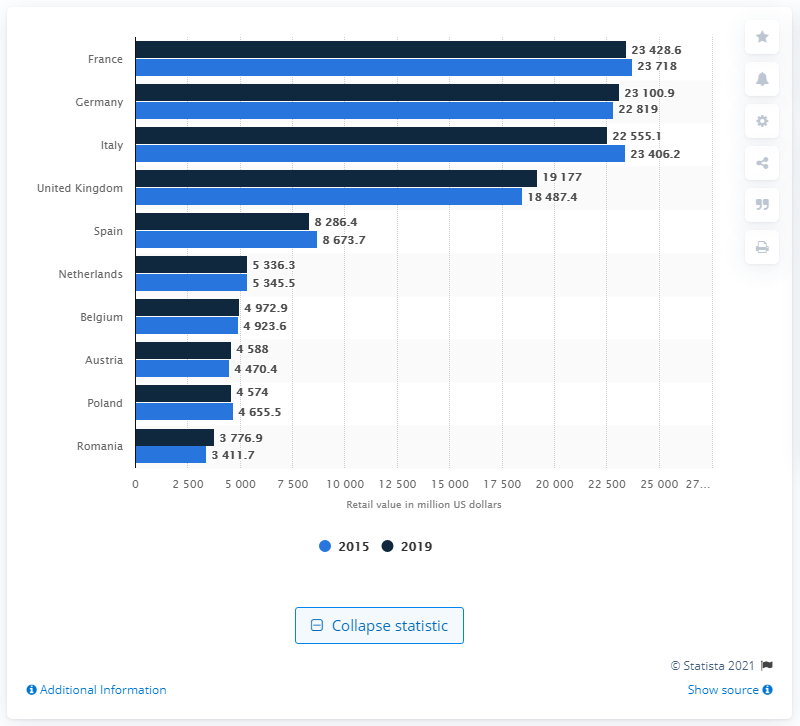Give some essential details in this illustration. The forecasted retail value of the bakery products market in France for the year 2019 is expected to be approximately 23,428.6 million. In 2015, the retail value of the bakery products market in France was approximately 23,718. The forecast retail value of the bakery products market in France in 2019 is estimated to be 23,428.6. 